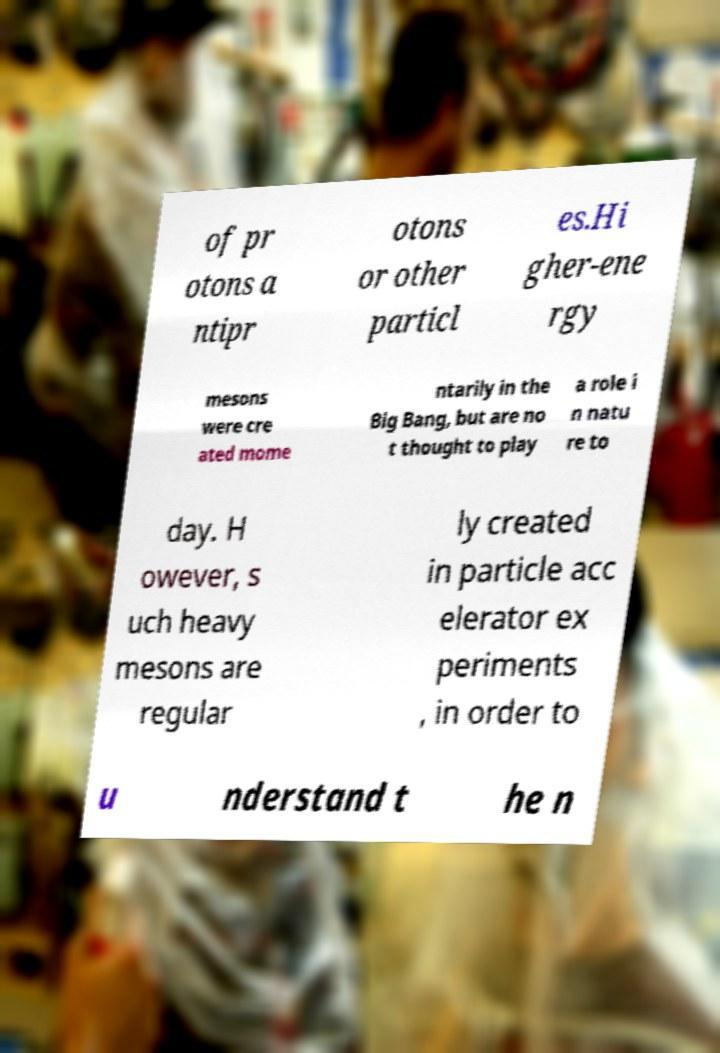Please read and relay the text visible in this image. What does it say? of pr otons a ntipr otons or other particl es.Hi gher-ene rgy mesons were cre ated mome ntarily in the Big Bang, but are no t thought to play a role i n natu re to day. H owever, s uch heavy mesons are regular ly created in particle acc elerator ex periments , in order to u nderstand t he n 